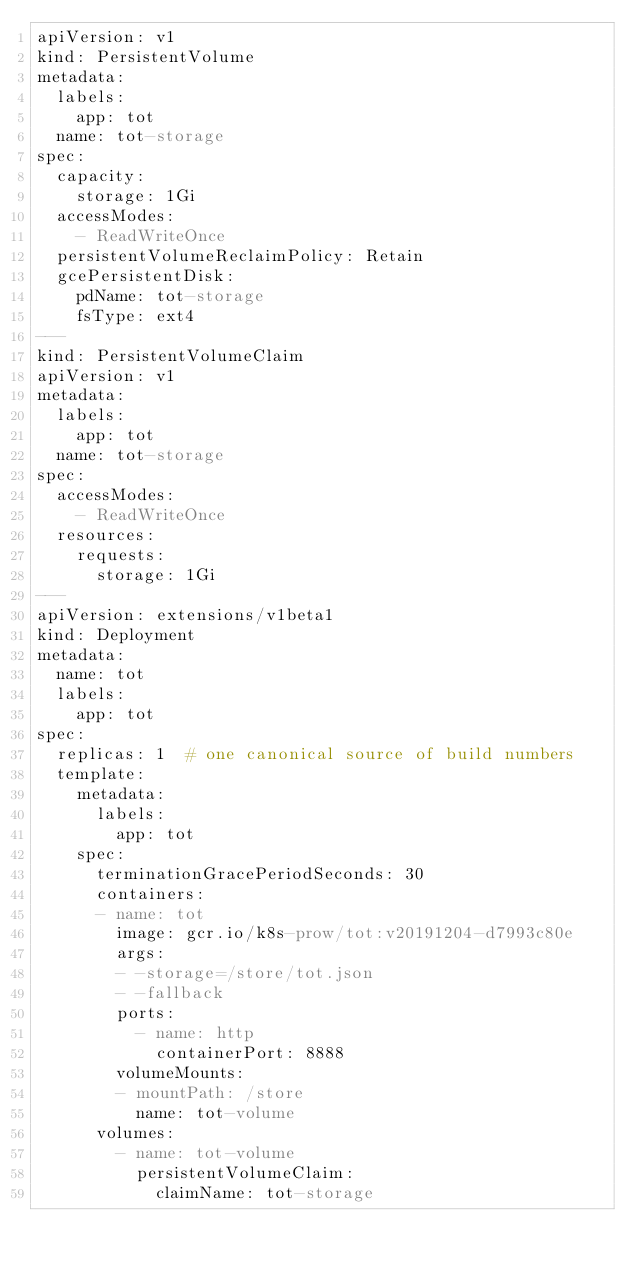Convert code to text. <code><loc_0><loc_0><loc_500><loc_500><_YAML_>apiVersion: v1
kind: PersistentVolume
metadata:
  labels:
    app: tot
  name: tot-storage
spec:
  capacity:
    storage: 1Gi
  accessModes:
    - ReadWriteOnce
  persistentVolumeReclaimPolicy: Retain
  gcePersistentDisk:
    pdName: tot-storage
    fsType: ext4
---
kind: PersistentVolumeClaim
apiVersion: v1
metadata:
  labels:
    app: tot
  name: tot-storage
spec:
  accessModes:
    - ReadWriteOnce
  resources:
    requests:
      storage: 1Gi
---
apiVersion: extensions/v1beta1
kind: Deployment
metadata:
  name: tot
  labels:
    app: tot
spec:
  replicas: 1  # one canonical source of build numbers
  template:
    metadata:
      labels:
        app: tot
    spec:
      terminationGracePeriodSeconds: 30
      containers:
      - name: tot
        image: gcr.io/k8s-prow/tot:v20191204-d7993c80e
        args:
        - -storage=/store/tot.json
        - -fallback
        ports:
          - name: http
            containerPort: 8888
        volumeMounts:
        - mountPath: /store
          name: tot-volume
      volumes:
        - name: tot-volume
          persistentVolumeClaim:
            claimName: tot-storage
</code> 